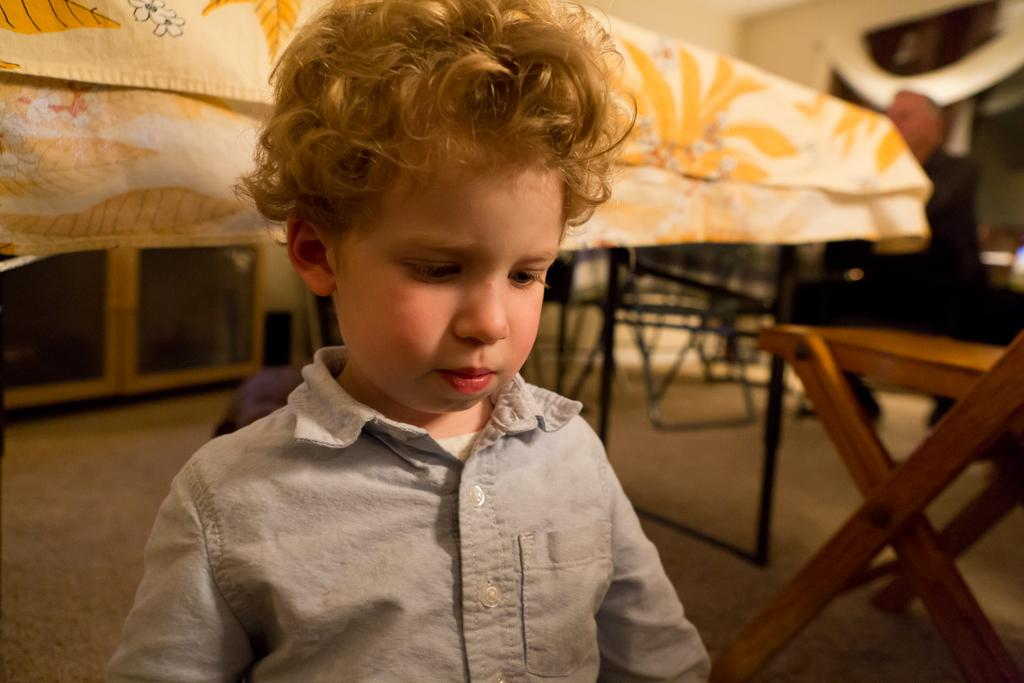What is the child doing in the image? The child is sitting on the floor in the image. What can be seen in the background of the image? There is a table and a man sitting on a chair in the background of the image. What type of oil is being used by the child in the image? There is no oil present in the image; the child is simply sitting on the floor. 